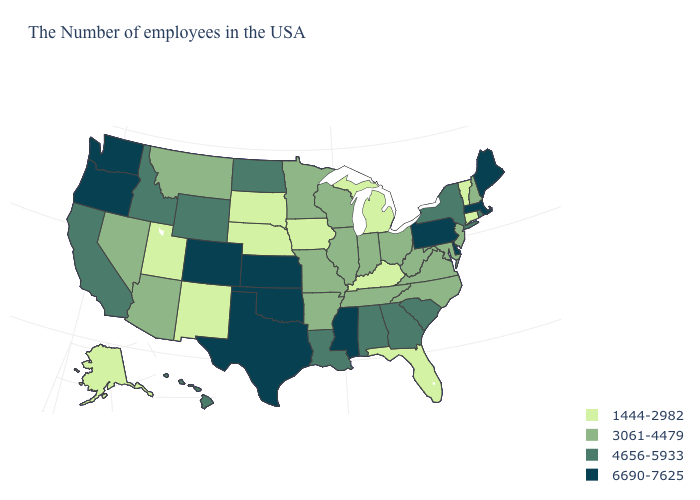Name the states that have a value in the range 4656-5933?
Answer briefly. Rhode Island, New York, South Carolina, Georgia, Alabama, Louisiana, North Dakota, Wyoming, Idaho, California, Hawaii. What is the value of California?
Quick response, please. 4656-5933. What is the value of Alabama?
Give a very brief answer. 4656-5933. What is the lowest value in the Northeast?
Write a very short answer. 1444-2982. Does the first symbol in the legend represent the smallest category?
Concise answer only. Yes. What is the value of Wyoming?
Keep it brief. 4656-5933. What is the highest value in the West ?
Write a very short answer. 6690-7625. What is the value of New York?
Keep it brief. 4656-5933. Does New York have the lowest value in the Northeast?
Keep it brief. No. What is the value of Iowa?
Answer briefly. 1444-2982. What is the highest value in the USA?
Keep it brief. 6690-7625. What is the value of Utah?
Keep it brief. 1444-2982. Name the states that have a value in the range 1444-2982?
Write a very short answer. Vermont, Connecticut, Florida, Michigan, Kentucky, Iowa, Nebraska, South Dakota, New Mexico, Utah, Alaska. Does the first symbol in the legend represent the smallest category?
Be succinct. Yes. What is the value of Tennessee?
Be succinct. 3061-4479. 